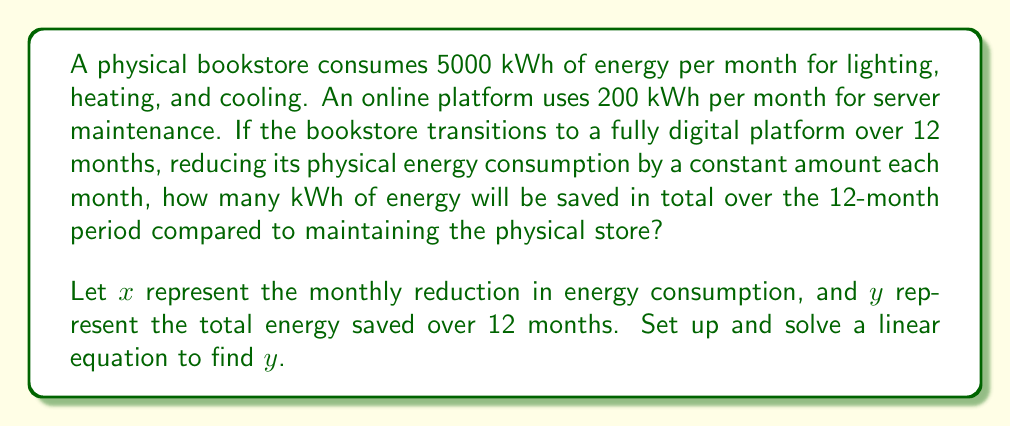Help me with this question. 1) First, let's set up an equation for the total energy saved over 12 months:

   $y = (x + 2x + 3x + ... + 12x) - (200 * 12)$

2) The series $(x + 2x + 3x + ... + 12x)$ is an arithmetic sequence with 12 terms.
   We can use the formula for the sum of an arithmetic sequence:
   $S_n = \frac{n(a_1 + a_n)}{2}$, where $n$ is the number of terms, $a_1$ is the first term, and $a_n$ is the last term.

3) In this case, $n = 12$, $a_1 = x$, and $a_{12} = 12x$. Substituting:

   $y = \frac{12(x + 12x)}{2} - 2400$

4) Simplify:
   $y = \frac{12(13x)}{2} - 2400 = 78x - 2400$

5) We know that after 12 months, the energy consumption should be reduced from 5000 kWh to 200 kWh.
   So, $12x = 4800$
   $x = 400$

6) Substitute $x = 400$ into our equation for $y$:
   $y = 78(400) - 2400 = 31200 - 2400 = 28800$

Therefore, 28800 kWh of energy will be saved over the 12-month period.
Answer: 28800 kWh 